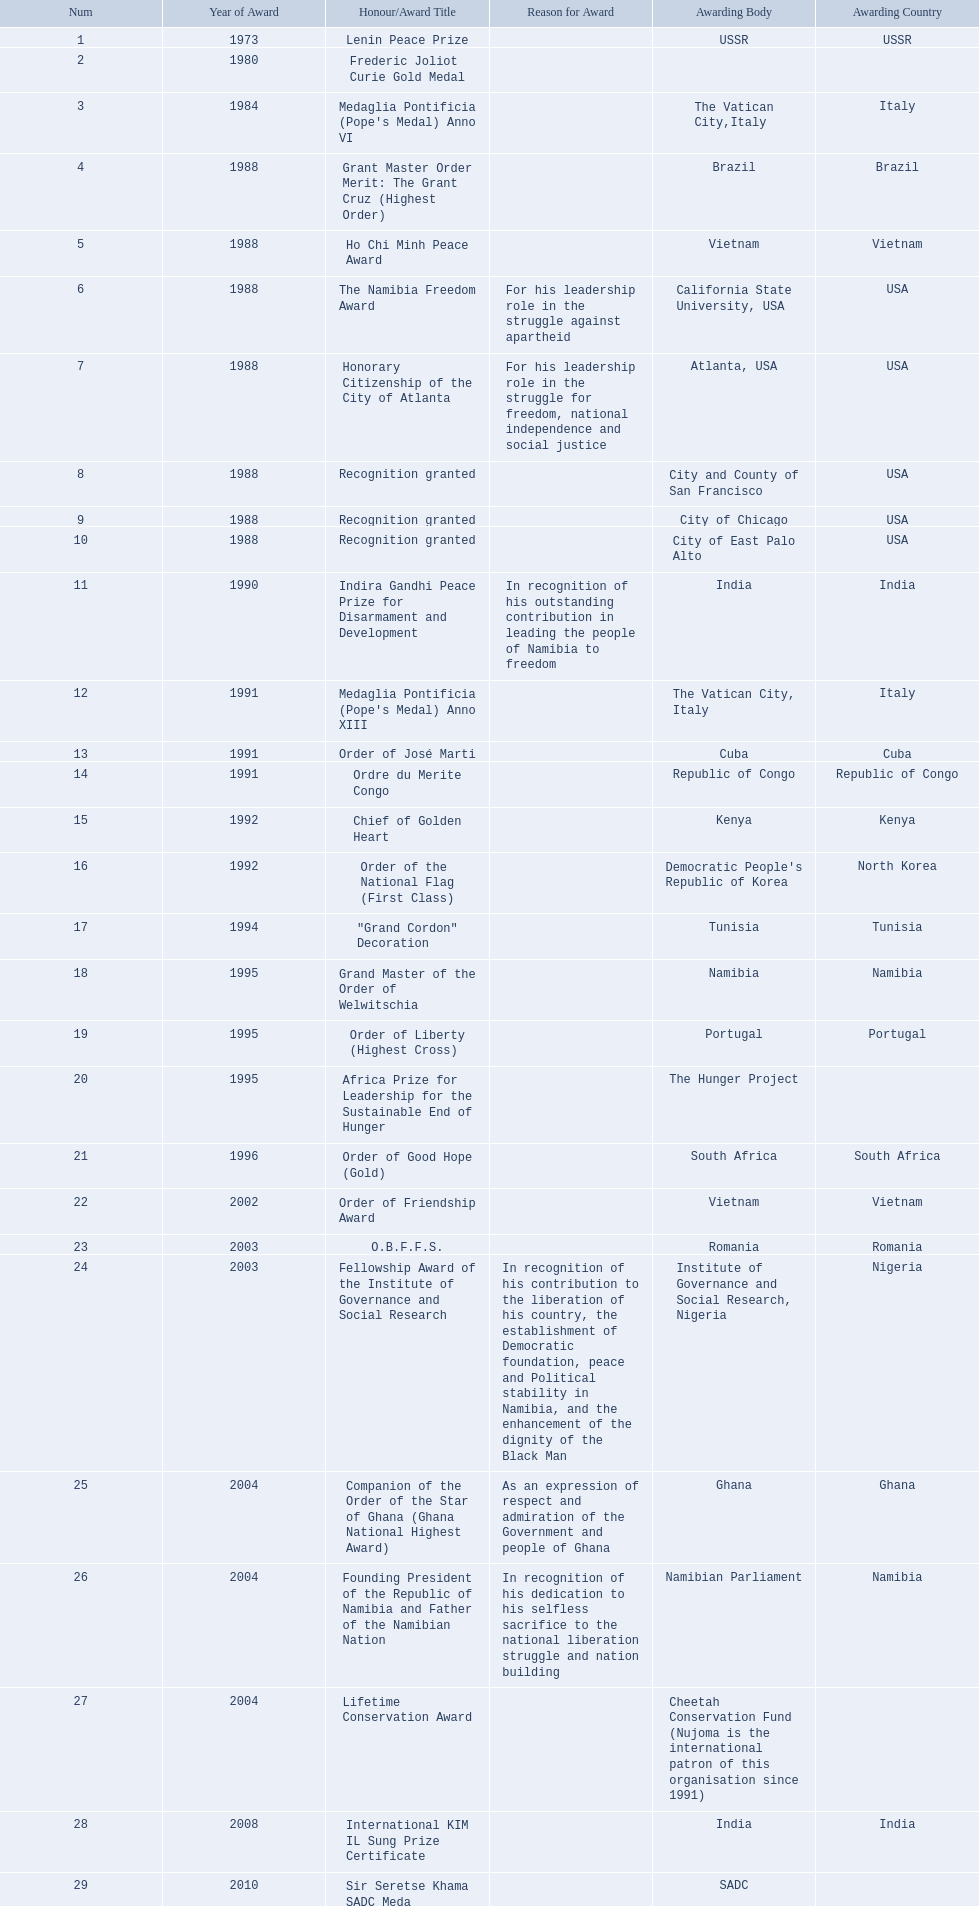What awards did sam nujoma win? 1, 1973, Lenin Peace Prize, Frederic Joliot Curie Gold Medal, Medaglia Pontificia (Pope's Medal) Anno VI, Grant Master Order Merit: The Grant Cruz (Highest Order), Ho Chi Minh Peace Award, The Namibia Freedom Award, Honorary Citizenship of the City of Atlanta, Recognition granted, Recognition granted, Recognition granted, Indira Gandhi Peace Prize for Disarmament and Development, Medaglia Pontificia (Pope's Medal) Anno XIII, Order of José Marti, Ordre du Merite Congo, Chief of Golden Heart, Order of the National Flag (First Class), "Grand Cordon" Decoration, Grand Master of the Order of Welwitschia, Order of Liberty (Highest Cross), Africa Prize for Leadership for the Sustainable End of Hunger, Order of Good Hope (Gold), Order of Friendship Award, O.B.F.F.S., Fellowship Award of the Institute of Governance and Social Research, Companion of the Order of the Star of Ghana (Ghana National Highest Award), Founding President of the Republic of Namibia and Father of the Namibian Nation, Lifetime Conservation Award, International KIM IL Sung Prize Certificate, Sir Seretse Khama SADC Meda. Who was the awarding body for the o.b.f.f.s award? Romania. 